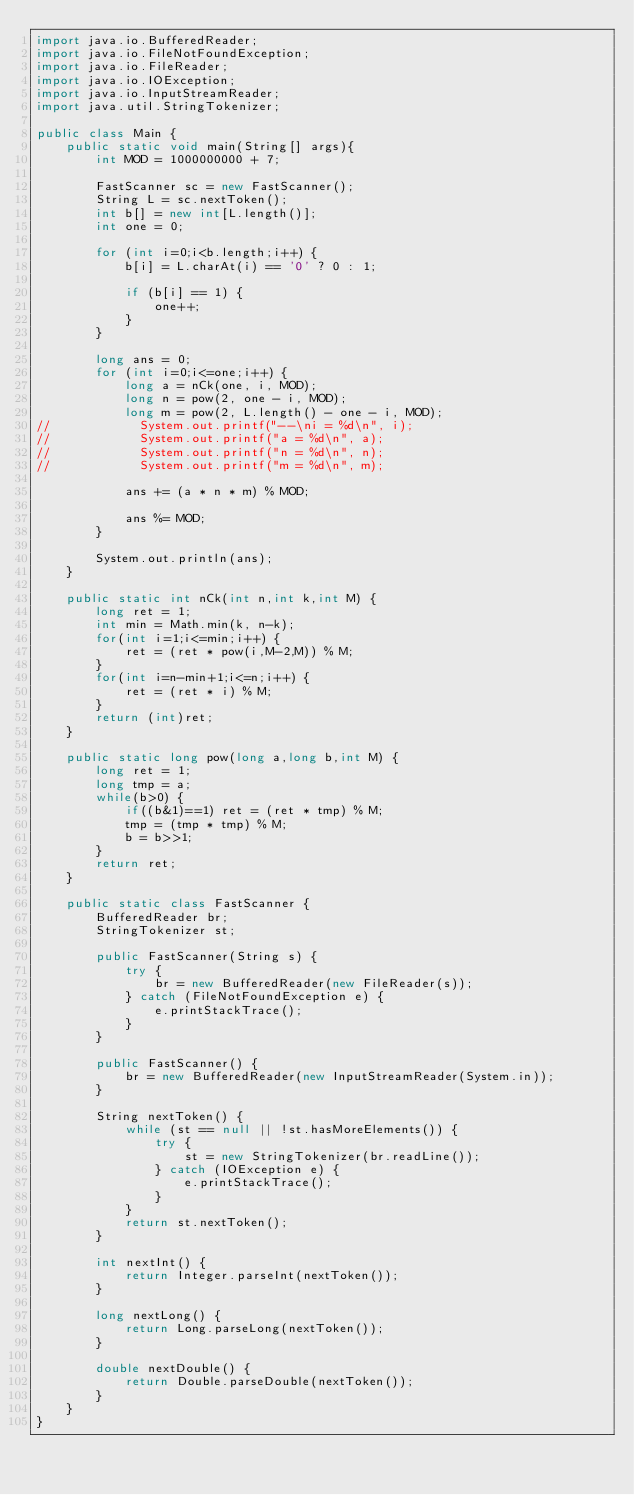Convert code to text. <code><loc_0><loc_0><loc_500><loc_500><_Java_>import java.io.BufferedReader;
import java.io.FileNotFoundException;
import java.io.FileReader;
import java.io.IOException;
import java.io.InputStreamReader;
import java.util.StringTokenizer;

public class Main {
    public static void main(String[] args){
        int MOD = 1000000000 + 7;

        FastScanner sc = new FastScanner();
        String L = sc.nextToken();
        int b[] = new int[L.length()];
        int one = 0;

        for (int i=0;i<b.length;i++) {
            b[i] = L.charAt(i) == '0' ? 0 : 1;

            if (b[i] == 1) {
                one++;
            }
        }

        long ans = 0;
        for (int i=0;i<=one;i++) {
            long a = nCk(one, i, MOD);
            long n = pow(2, one - i, MOD);
            long m = pow(2, L.length() - one - i, MOD);
//            System.out.printf("--\ni = %d\n", i);
//            System.out.printf("a = %d\n", a);
//            System.out.printf("n = %d\n", n);
//            System.out.printf("m = %d\n", m);

            ans += (a * n * m) % MOD;

            ans %= MOD;
        }

        System.out.println(ans);
    }

    public static int nCk(int n,int k,int M) {
        long ret = 1;
        int min = Math.min(k, n-k);
        for(int i=1;i<=min;i++) {
            ret = (ret * pow(i,M-2,M)) % M;
        }
        for(int i=n-min+1;i<=n;i++) {
            ret = (ret * i) % M;
        }
        return (int)ret;
    }

    public static long pow(long a,long b,int M) {
        long ret = 1;
        long tmp = a;
        while(b>0) {
            if((b&1)==1) ret = (ret * tmp) % M;
            tmp = (tmp * tmp) % M;
            b = b>>1;
        }
        return ret;
    }

    public static class FastScanner {
        BufferedReader br;
        StringTokenizer st;

        public FastScanner(String s) {
            try {
                br = new BufferedReader(new FileReader(s));
            } catch (FileNotFoundException e) {
                e.printStackTrace();
            }
        }

        public FastScanner() {
            br = new BufferedReader(new InputStreamReader(System.in));
        }

        String nextToken() {
            while (st == null || !st.hasMoreElements()) {
                try {
                    st = new StringTokenizer(br.readLine());
                } catch (IOException e) {
                    e.printStackTrace();
                }
            }
            return st.nextToken();
        }

        int nextInt() {
            return Integer.parseInt(nextToken());
        }

        long nextLong() {
            return Long.parseLong(nextToken());
        }

        double nextDouble() {
            return Double.parseDouble(nextToken());
        }
    }
}</code> 